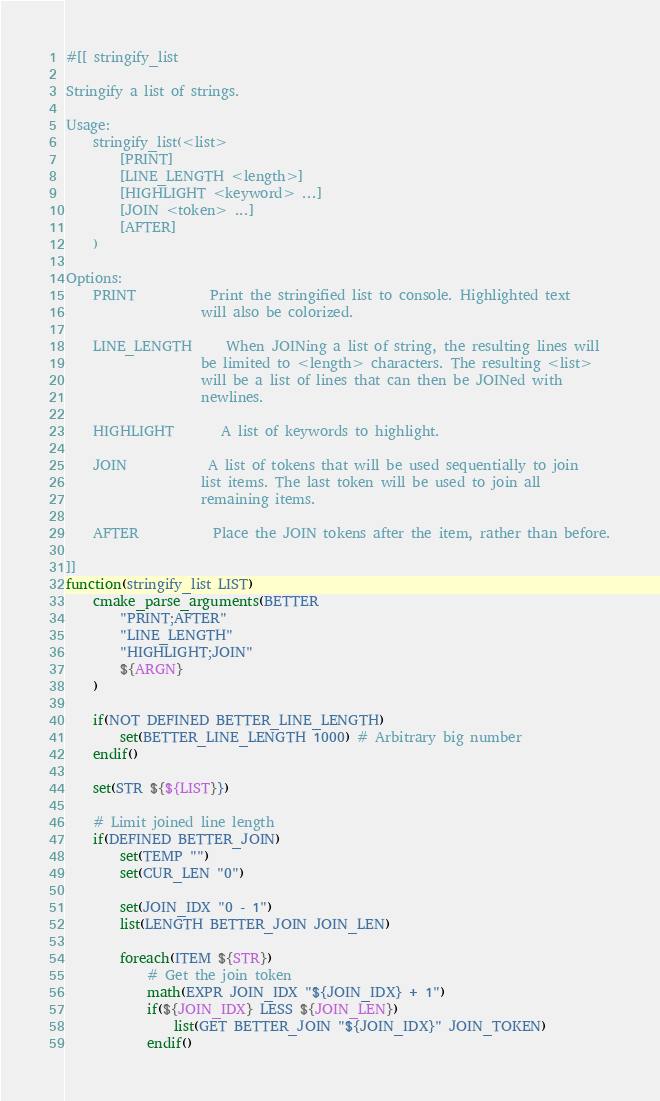<code> <loc_0><loc_0><loc_500><loc_500><_CMake_>
#[[ stringify_list

Stringify a list of strings.

Usage:
    stringify_list(<list>
        [PRINT]
        [LINE_LENGTH <length>]
        [HIGHLIGHT <keyword> ...]
        [JOIN <token> ...]
        [AFTER]
    )

Options:
    PRINT           Print the stringified list to console. Highlighted text
                    will also be colorized.

    LINE_LENGTH     When JOINing a list of string, the resulting lines will
                    be limited to <length> characters. The resulting <list>
                    will be a list of lines that can then be JOINed with
                    newlines.

    HIGHLIGHT       A list of keywords to highlight.

    JOIN            A list of tokens that will be used sequentially to join
                    list items. The last token will be used to join all
                    remaining items.

    AFTER           Place the JOIN tokens after the item, rather than before.

]]
function(stringify_list LIST)
    cmake_parse_arguments(BETTER
        "PRINT;AFTER"
        "LINE_LENGTH"
        "HIGHLIGHT;JOIN"
        ${ARGN}
    )

    if(NOT DEFINED BETTER_LINE_LENGTH)
        set(BETTER_LINE_LENGTH 1000) # Arbitrary big number
    endif()

    set(STR ${${LIST}})

    # Limit joined line length
    if(DEFINED BETTER_JOIN)
        set(TEMP "")
        set(CUR_LEN "0")

        set(JOIN_IDX "0 - 1")
        list(LENGTH BETTER_JOIN JOIN_LEN)

        foreach(ITEM ${STR})
            # Get the join token
            math(EXPR JOIN_IDX "${JOIN_IDX} + 1")
            if(${JOIN_IDX} LESS ${JOIN_LEN})
                list(GET BETTER_JOIN "${JOIN_IDX}" JOIN_TOKEN)
            endif()</code> 